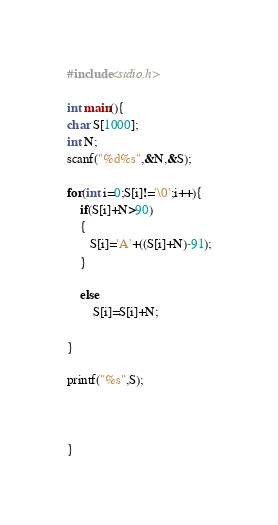Convert code to text. <code><loc_0><loc_0><loc_500><loc_500><_C_>#include<stdio.h>

int main(){
char S[1000];
int N;
scanf("%d%s",&N,&S);

for(int i=0;S[i]!='\0';i++){
    if(S[i]+N>90)
    {
       S[i]='A'+((S[i]+N)-91);
    }

    else
        S[i]=S[i]+N;

}

printf("%s",S);



}
</code> 